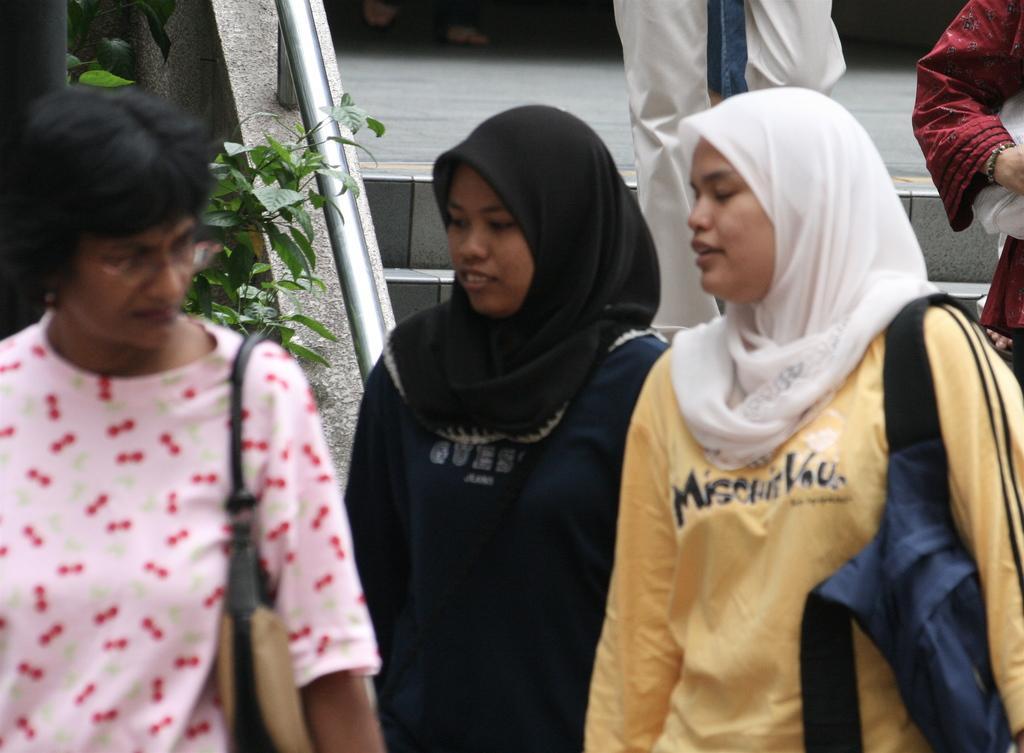What can be seen in the image involving multiple individuals? There is a group of people in the image. How can the attire of the people be described? The people are wearing different color dresses. Are any of the people carrying any items? Yes, two people are wearing bags. What can be seen in the background of the image? There is a plant and railing in the background of the image. What type of engine can be seen powering the plant in the background? There is no engine present in the image, and the plant is not being powered by any engine. 